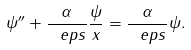<formula> <loc_0><loc_0><loc_500><loc_500>\psi ^ { \prime \prime } + \frac { \alpha } { \ e p s } \frac { \psi } { x } = \frac { \alpha } { \ e p s } \psi .</formula> 